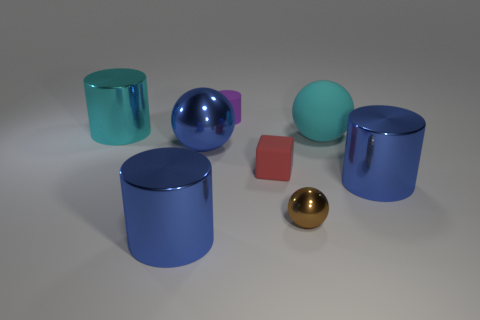What materials do the objects in the image appear to be made of? The objects in the image seem to have a variety of materials. The cylinders and the sphere appear to be made of a smooth, reflective metallic or plastic-like material, while the brown and gold objects might be made of materials with a matte finish, possibly resembling wood or metal. 